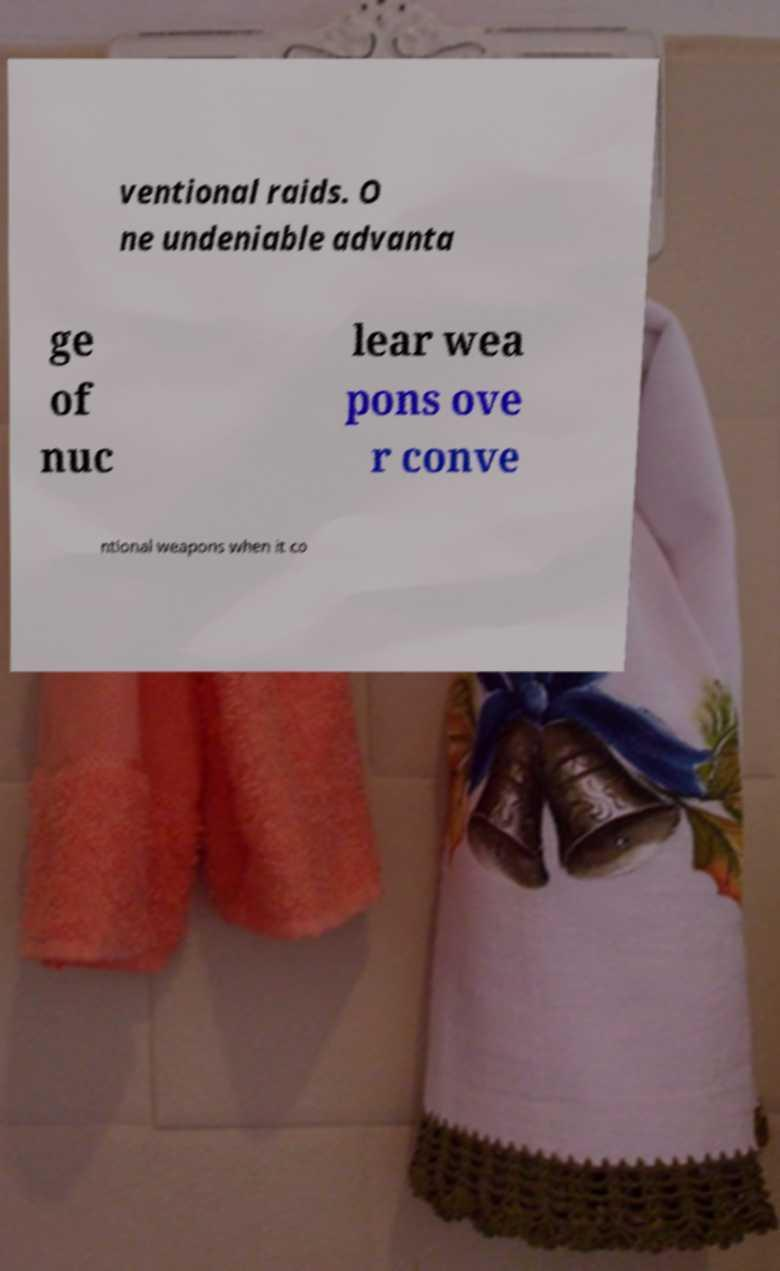I need the written content from this picture converted into text. Can you do that? ventional raids. O ne undeniable advanta ge of nuc lear wea pons ove r conve ntional weapons when it co 